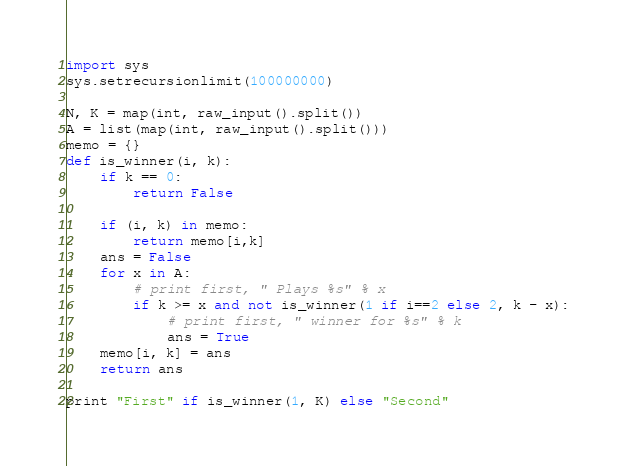<code> <loc_0><loc_0><loc_500><loc_500><_Python_>import sys
sys.setrecursionlimit(100000000)

N, K = map(int, raw_input().split())
A = list(map(int, raw_input().split()))
memo = {}
def is_winner(i, k):
    if k == 0:
        return False

    if (i, k) in memo:
        return memo[i,k]
    ans = False
    for x in A:
        # print first, " Plays %s" % x
        if k >= x and not is_winner(1 if i==2 else 2, k - x):
            # print first, " winner for %s" % k
            ans = True
    memo[i, k] = ans
    return ans

print "First" if is_winner(1, K) else "Second"
</code> 